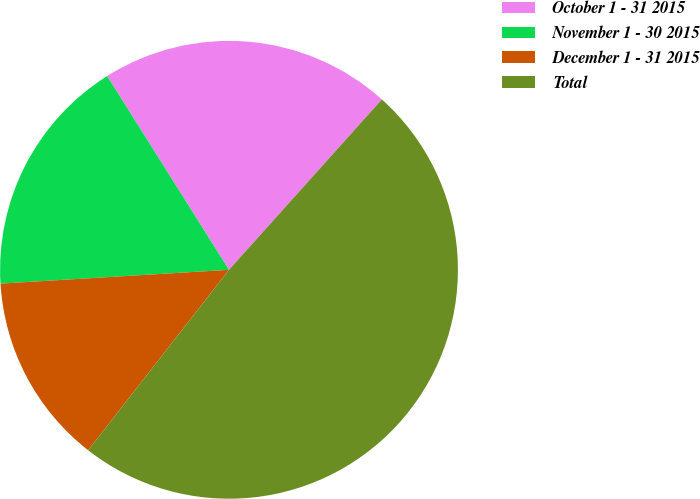Convert chart to OTSL. <chart><loc_0><loc_0><loc_500><loc_500><pie_chart><fcel>October 1 - 31 2015<fcel>November 1 - 30 2015<fcel>December 1 - 31 2015<fcel>Total<nl><fcel>20.57%<fcel>17.03%<fcel>13.49%<fcel>48.91%<nl></chart> 